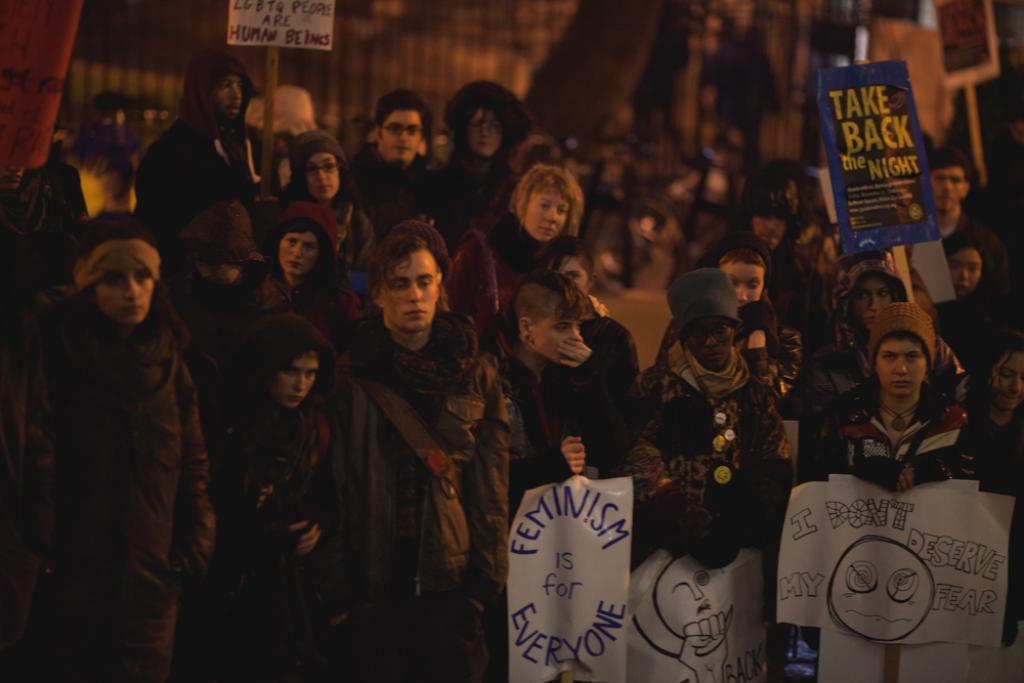How many people are present in the image? There are many people in the image. What are some people wearing in the image? Some people are wearing caps in the image. What are some people holding in the image? Some people are holding placards in the image. Can you describe the background of the image? The background of the image is blurry. What type of table can be seen in the image? There is no table present in the image. What scene is depicted in the image? The image does not depict a specific scene; it simply shows many people, some wearing caps and holding placards. 